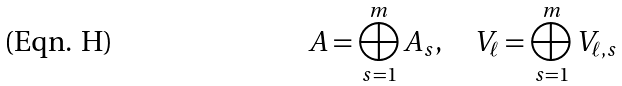Convert formula to latex. <formula><loc_0><loc_0><loc_500><loc_500>A = \bigoplus _ { s = 1 } ^ { m } A _ { s } , \quad V _ { \ell } = \bigoplus _ { s = 1 } ^ { m } V _ { \ell , s }</formula> 